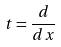Convert formula to latex. <formula><loc_0><loc_0><loc_500><loc_500>t = \frac { d } { d x }</formula> 